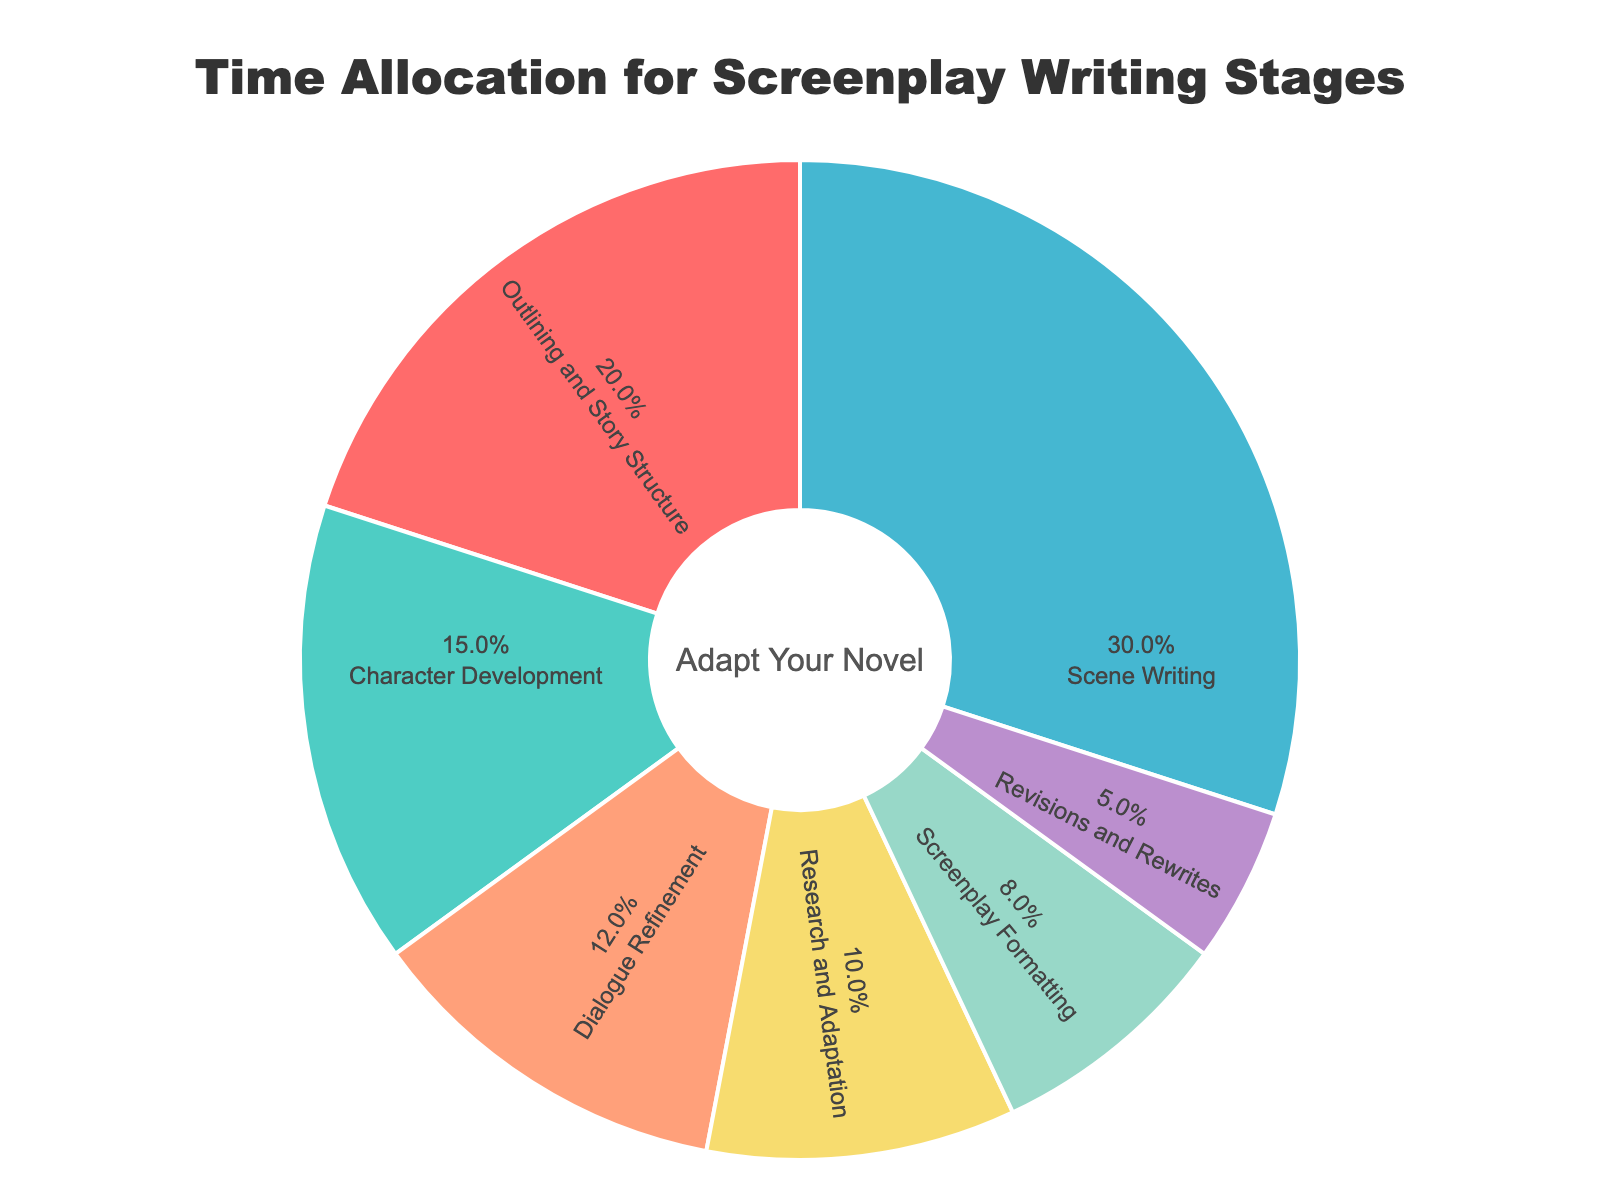what stage takes the highest percentage of time? By looking at the pie chart, the section with the largest area and percentage label will indicate the stage that takes the highest percentage of time, which is represented by scene writing at 30%.
Answer: Scene Writing How much more time is allocated to dialogue refinement compared to screenplay formatting? Compare the percentage labels of dialogue refinement and screenplay formatting. Dialogue refinement is 12% and screenplay formatting is 8%. The difference is 12% - 8% = 4%.
Answer: 4% What is the combined percentage of time spent on research and adaptation, and revisions and rewrites? Sum the percentages of research and adaptation (10%) and revisions and rewrites (5%). Combined percentage is 10% + 5% = 15%.
Answer: 15% Which stage has a smaller percentage: character development or outlining and story structure? Compare the percentage labels of character development and outlining and story structure. Character development is 15% and outlining and story structure is 20%. Thus, character development has the smaller percentage.
Answer: Character Development Out of dialogue refinement, screenplay formatting, and revisions and rewrites, which stage has the lowest percentage? Compare the percentage labels of dialogue refinement (12%), screenplay formatting (8%), and revisions and rewrites (5%). Revisions and rewrites have the lowest percentage.
Answer: Revisions and Rewrites If approximately 60 hours were spent on the entire project, how much time was allocated to character development? Calculate 15% of 60 hours. This is 0.15 * 60 = 9 hours.
Answer: 9 hours What is the total percentage of time allocated to outlining and story structure and scene writing? Sum the percentages of outlining and story structure (20%) and scene writing (30%). Total percentage is 20% + 30% = 50%.
Answer: 50% Which stage is represented by the blue section in the pie chart? Identify the color blue in the pie chart and observe the label associated with that section. It corresponds to scene writing.
Answer: Scene Writing Is the percentage of time spent on character development greater than the percentage of time spent on research and adaptation? Compare the percentage labels of character development (15%) and research and adaptation (10%). Character development has a greater percentage.
Answer: Yes 